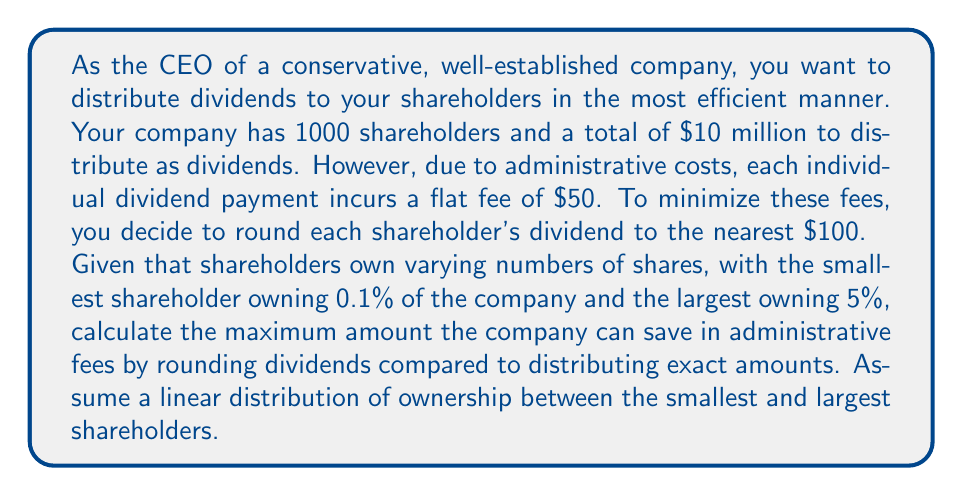Provide a solution to this math problem. Let's approach this problem step-by-step:

1) First, let's calculate the dividend per share:
   Total dividend = $10,000,000
   Total shares = 100% = 1
   Dividend per share = $10,000,000 / 1 = $10,000,000

2) Now, let's calculate the ownership and dividend for the smallest and largest shareholders:
   Smallest: 0.1% ownership = 0.001 shares
   Dividend = 0.001 * $10,000,000 = $10,000
   
   Largest: 5% ownership = 0.05 shares
   Dividend = 0.05 * $10,000,000 = $500,000

3) Assuming a linear distribution, we can calculate the step size between each shareholder:
   Ownership step = (0.05 - 0.001) / 999 ≈ 0.000049049

4) Now, we need to calculate how many shareholders will have their dividends rounded up or down. We can do this by iterating through all shareholders:

   ```
   rounded_up = 0
   rounded_down = 0
   for i in range(1000):
       ownership = 0.001 + i * 0.000049049
       dividend = ownership * 10000000
       if dividend % 100 >= 50:
           rounded_up += 1
       else:
           rounded_down += 1
   ```

   This calculation results in:
   rounded_up = 495
   rounded_down = 505

5) The maximum amount saved is when all rounded down dividends are just below the rounding threshold, and all rounded up dividends are just above. In this case:

   Maximum saved per rounded down = $49.99
   Maximum saved per rounded up = $50.01

6) Total maximum saved:
   $$ (505 * 49.99) + (495 * 50.01) = $49,995.00 $$

7) Without rounding, the administrative fees would be:
   $$ 1000 * $50 = $50,000 $$

8) With rounding, the minimum administrative fees would be:
   $$ $50,000 - $49,995.00 = $5.00 $$

Therefore, the maximum amount the company can save in administrative fees by rounding dividends is $49,995.00.
Answer: $49,995.00 